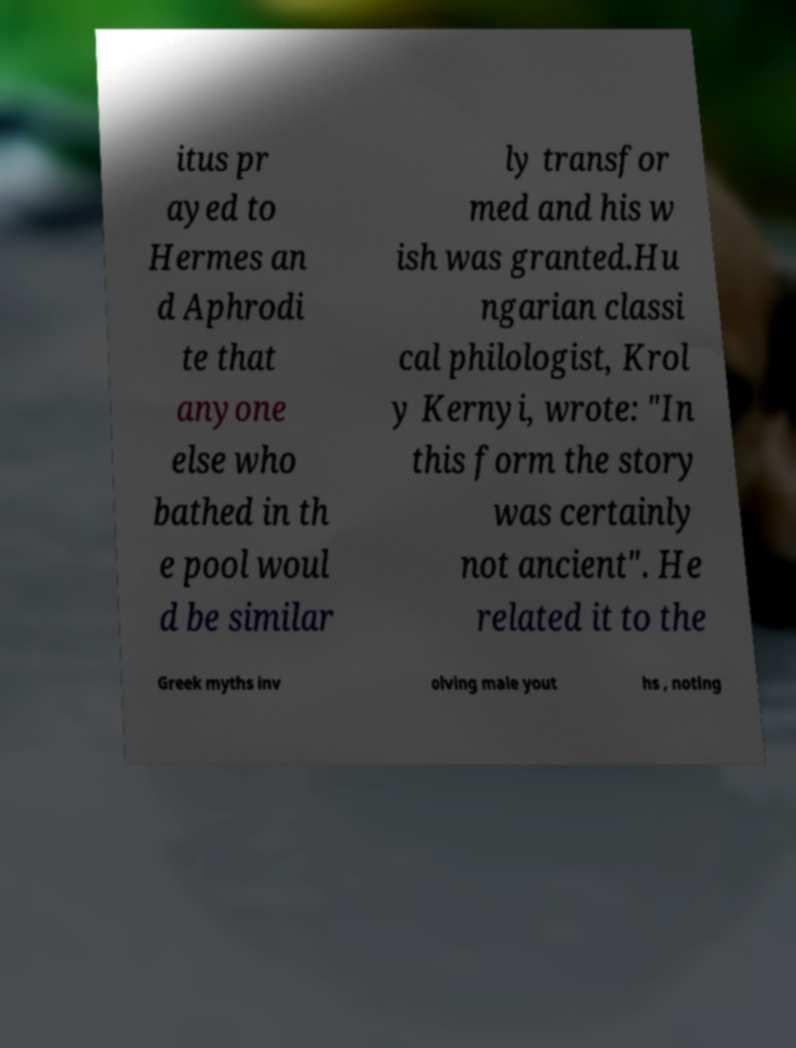For documentation purposes, I need the text within this image transcribed. Could you provide that? itus pr ayed to Hermes an d Aphrodi te that anyone else who bathed in th e pool woul d be similar ly transfor med and his w ish was granted.Hu ngarian classi cal philologist, Krol y Kernyi, wrote: "In this form the story was certainly not ancient". He related it to the Greek myths inv olving male yout hs , noting 